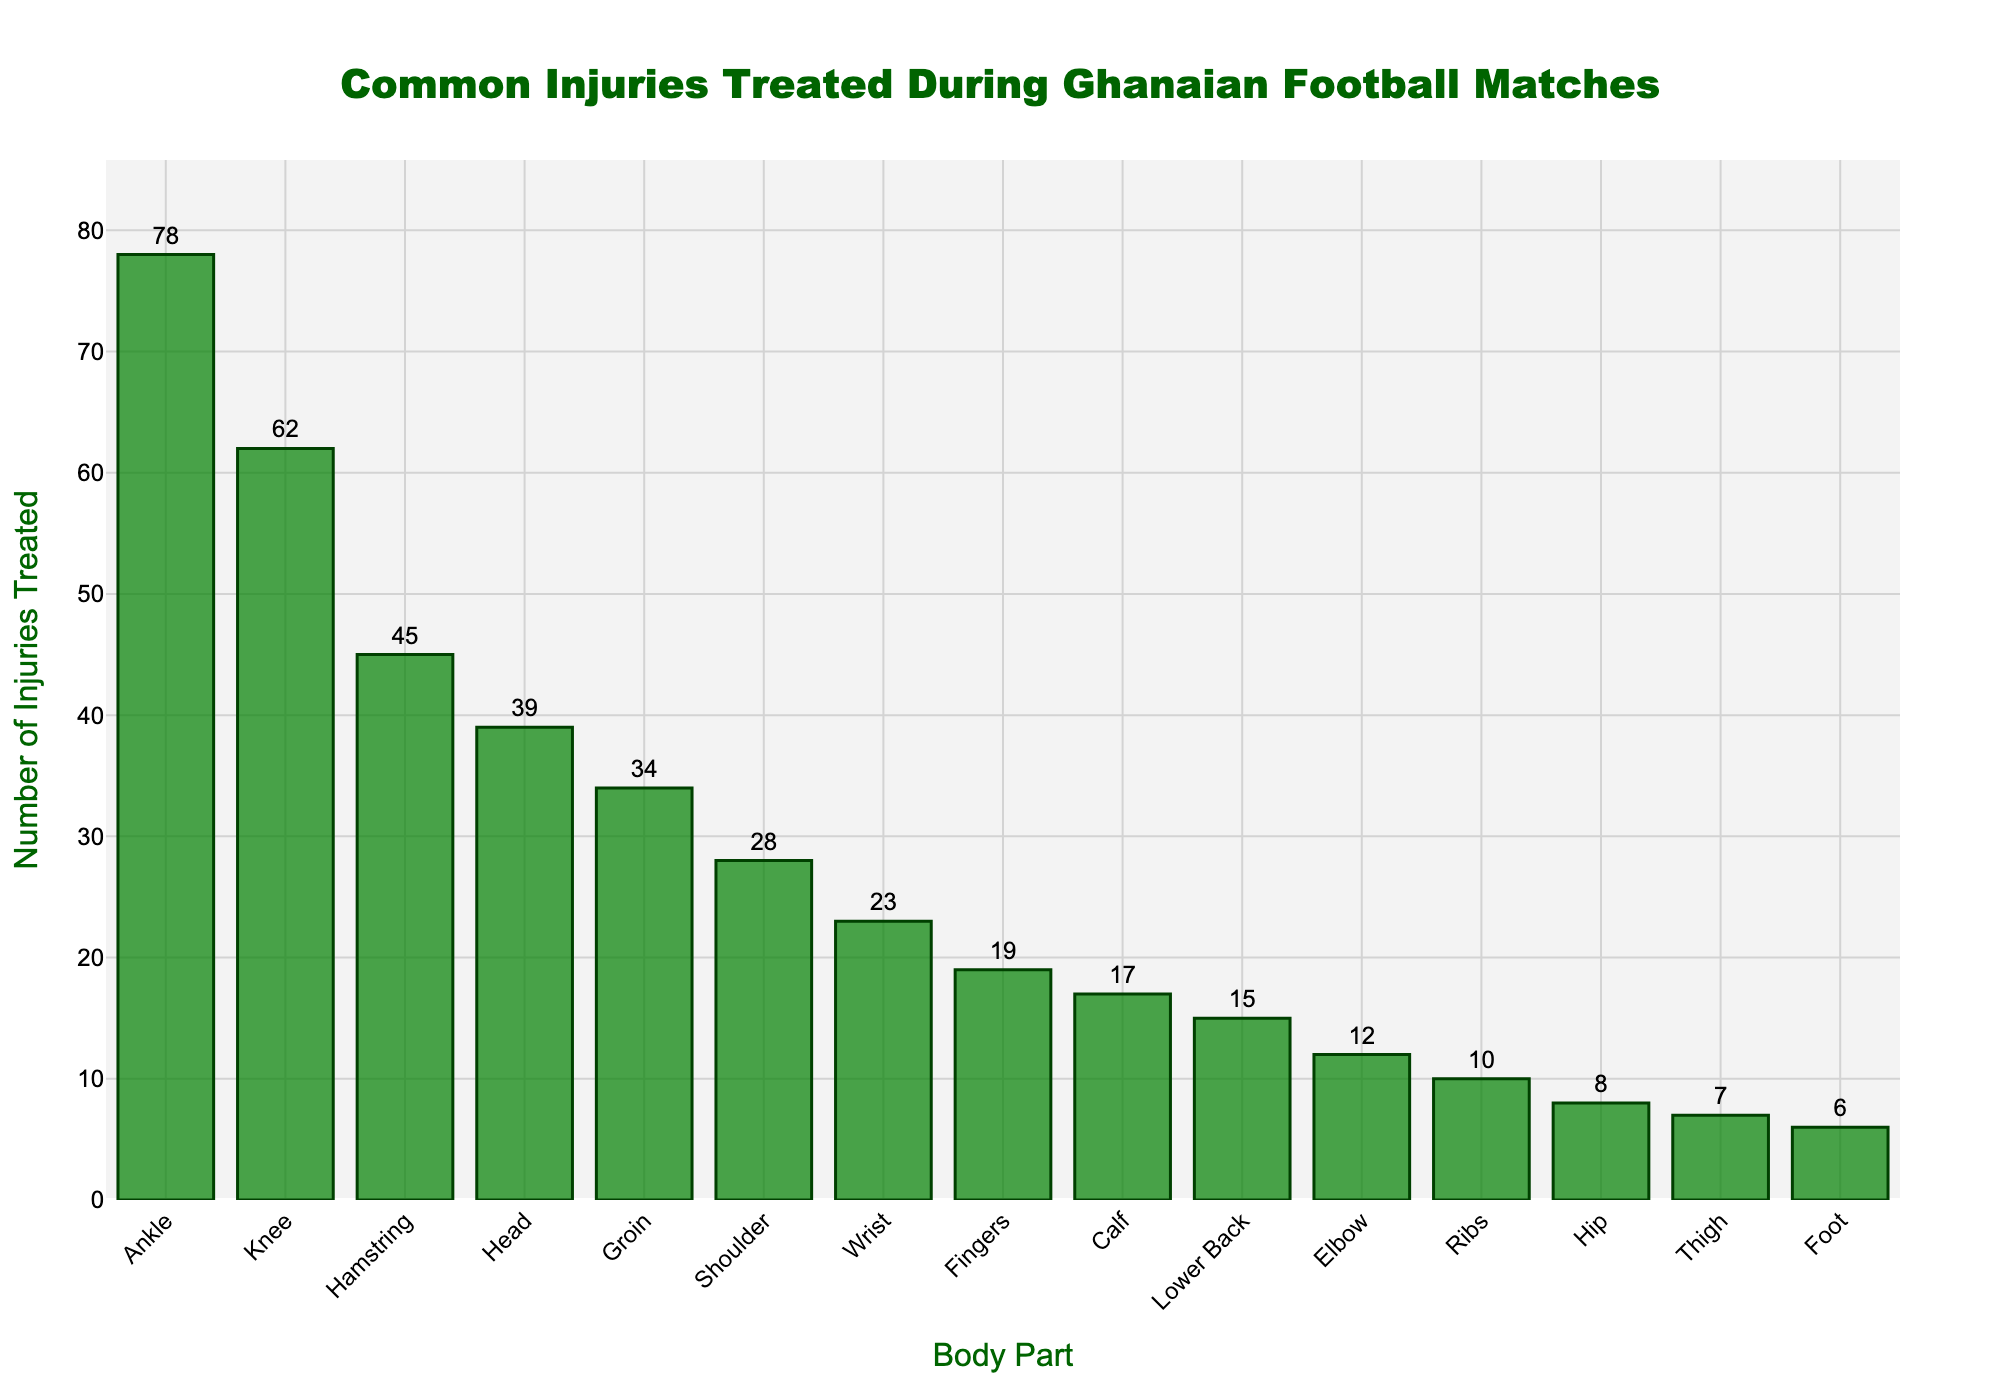Which body part has the highest number of injuries treated? The bar representing the 'Ankle' is the tallest, indicating it has the highest number of injuries treated.
Answer: Ankle Which body part has the lowest number of injuries treated? The bar for the 'Foot' is the shortest, indicating it has the lowest number of injuries treated.
Answer: Foot How many more injuries were treated for the ankle compared to the knee? The height of the 'Ankle' bar is 78 and 'Knee' bar is 62. The difference is 78 - 62 = 16.
Answer: 16 What is the total number of injuries treated for the ankle, knee, and hamstring? Add the heights of the bars: Ankle (78) + Knee (62) + Hamstring (45) = 185.
Answer: 185 What is the difference in the number of injuries treated between the groin and the wrist? The 'Groin' bar has 34 injuries treated and the 'Wrist' bar has 23. The difference is 34 - 23 = 11.
Answer: 11 Is the number of injuries treated for the head greater than the number of injuries treated for the shoulder? The 'Head' bar shows 39 injuries, and the 'Shoulder' bar shows 28. Since 39 > 28, the head has more injuries.
Answer: Yes Are the injuries treated for the ribs and hip combined greater than the injuries treated for the hamstring? Combined injuries for 'Ribs' (10) and 'Hip' (8) are 10 + 8 = 18, which is less than 'Hamstring' at 45.
Answer: No What is the median number of injuries treated? The data sorted in ascending order: 6 (Foot), 7 (Thigh), 8 (Hip), 10 (Ribs), 12 (Elbow), 15 (Lower Back), 17 (Calf), 19 (Fingers), 23 (Wrist), 28 (Shoulder), 34 (Groin), 39 (Head), 45 (Hamstring), 62 (Knee), 78 (Ankle). The median is the 8th value, which is 'Fingers' at 19.
Answer: 19 How many injuries were treated for the less common injuries (those with a value under 20)? These are Finger (19), Calf (17), Lower Back (15), Elbow (12), Ribs (10), Hip (8), Thigh (7), Foot (6). Adding them gives 19 + 17 + 15 + 12 + 10 + 8 + 7 + 6 = 94.
Answer: 94 